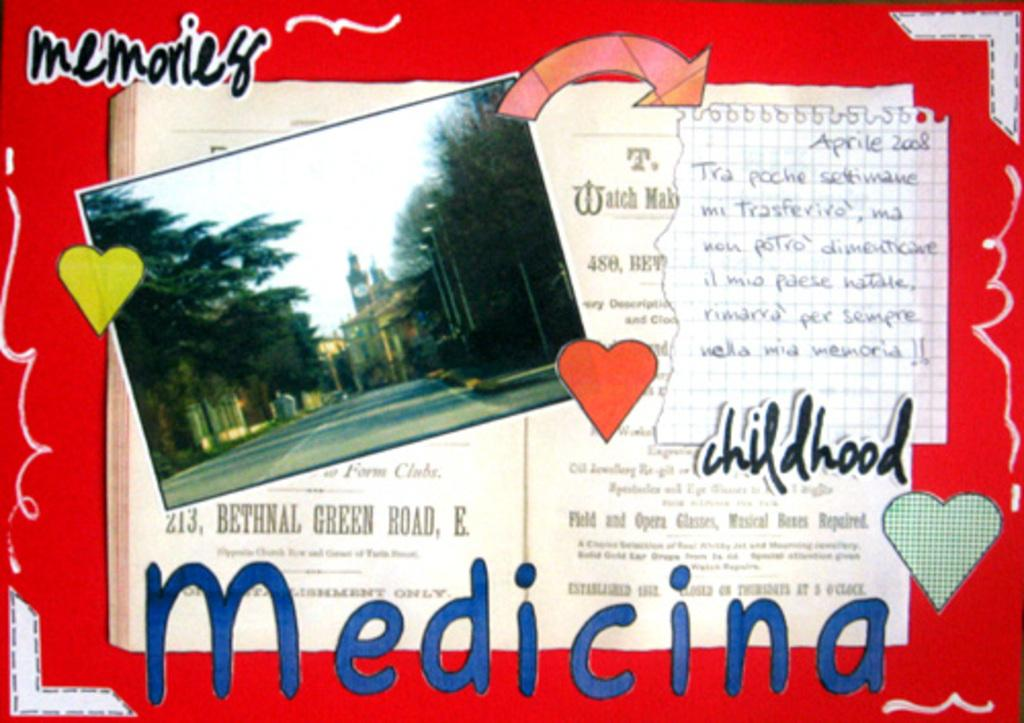<image>
Create a compact narrative representing the image presented. A red postcard with the words memories and childhood typed out on them. 